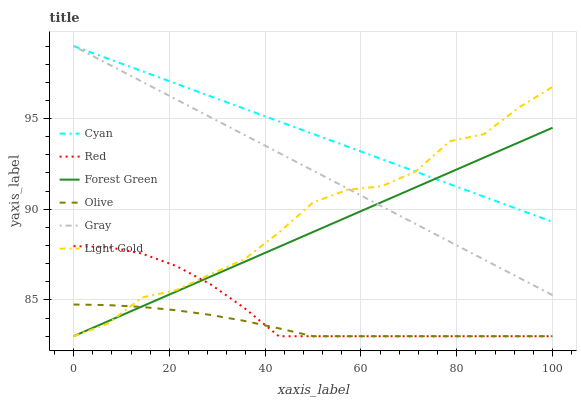Does Olive have the minimum area under the curve?
Answer yes or no. Yes. Does Cyan have the maximum area under the curve?
Answer yes or no. Yes. Does Forest Green have the minimum area under the curve?
Answer yes or no. No. Does Forest Green have the maximum area under the curve?
Answer yes or no. No. Is Cyan the smoothest?
Answer yes or no. Yes. Is Light Gold the roughest?
Answer yes or no. Yes. Is Forest Green the smoothest?
Answer yes or no. No. Is Forest Green the roughest?
Answer yes or no. No. Does Forest Green have the lowest value?
Answer yes or no. Yes. Does Cyan have the lowest value?
Answer yes or no. No. Does Cyan have the highest value?
Answer yes or no. Yes. Does Forest Green have the highest value?
Answer yes or no. No. Is Red less than Gray?
Answer yes or no. Yes. Is Cyan greater than Olive?
Answer yes or no. Yes. Does Red intersect Forest Green?
Answer yes or no. Yes. Is Red less than Forest Green?
Answer yes or no. No. Is Red greater than Forest Green?
Answer yes or no. No. Does Red intersect Gray?
Answer yes or no. No. 